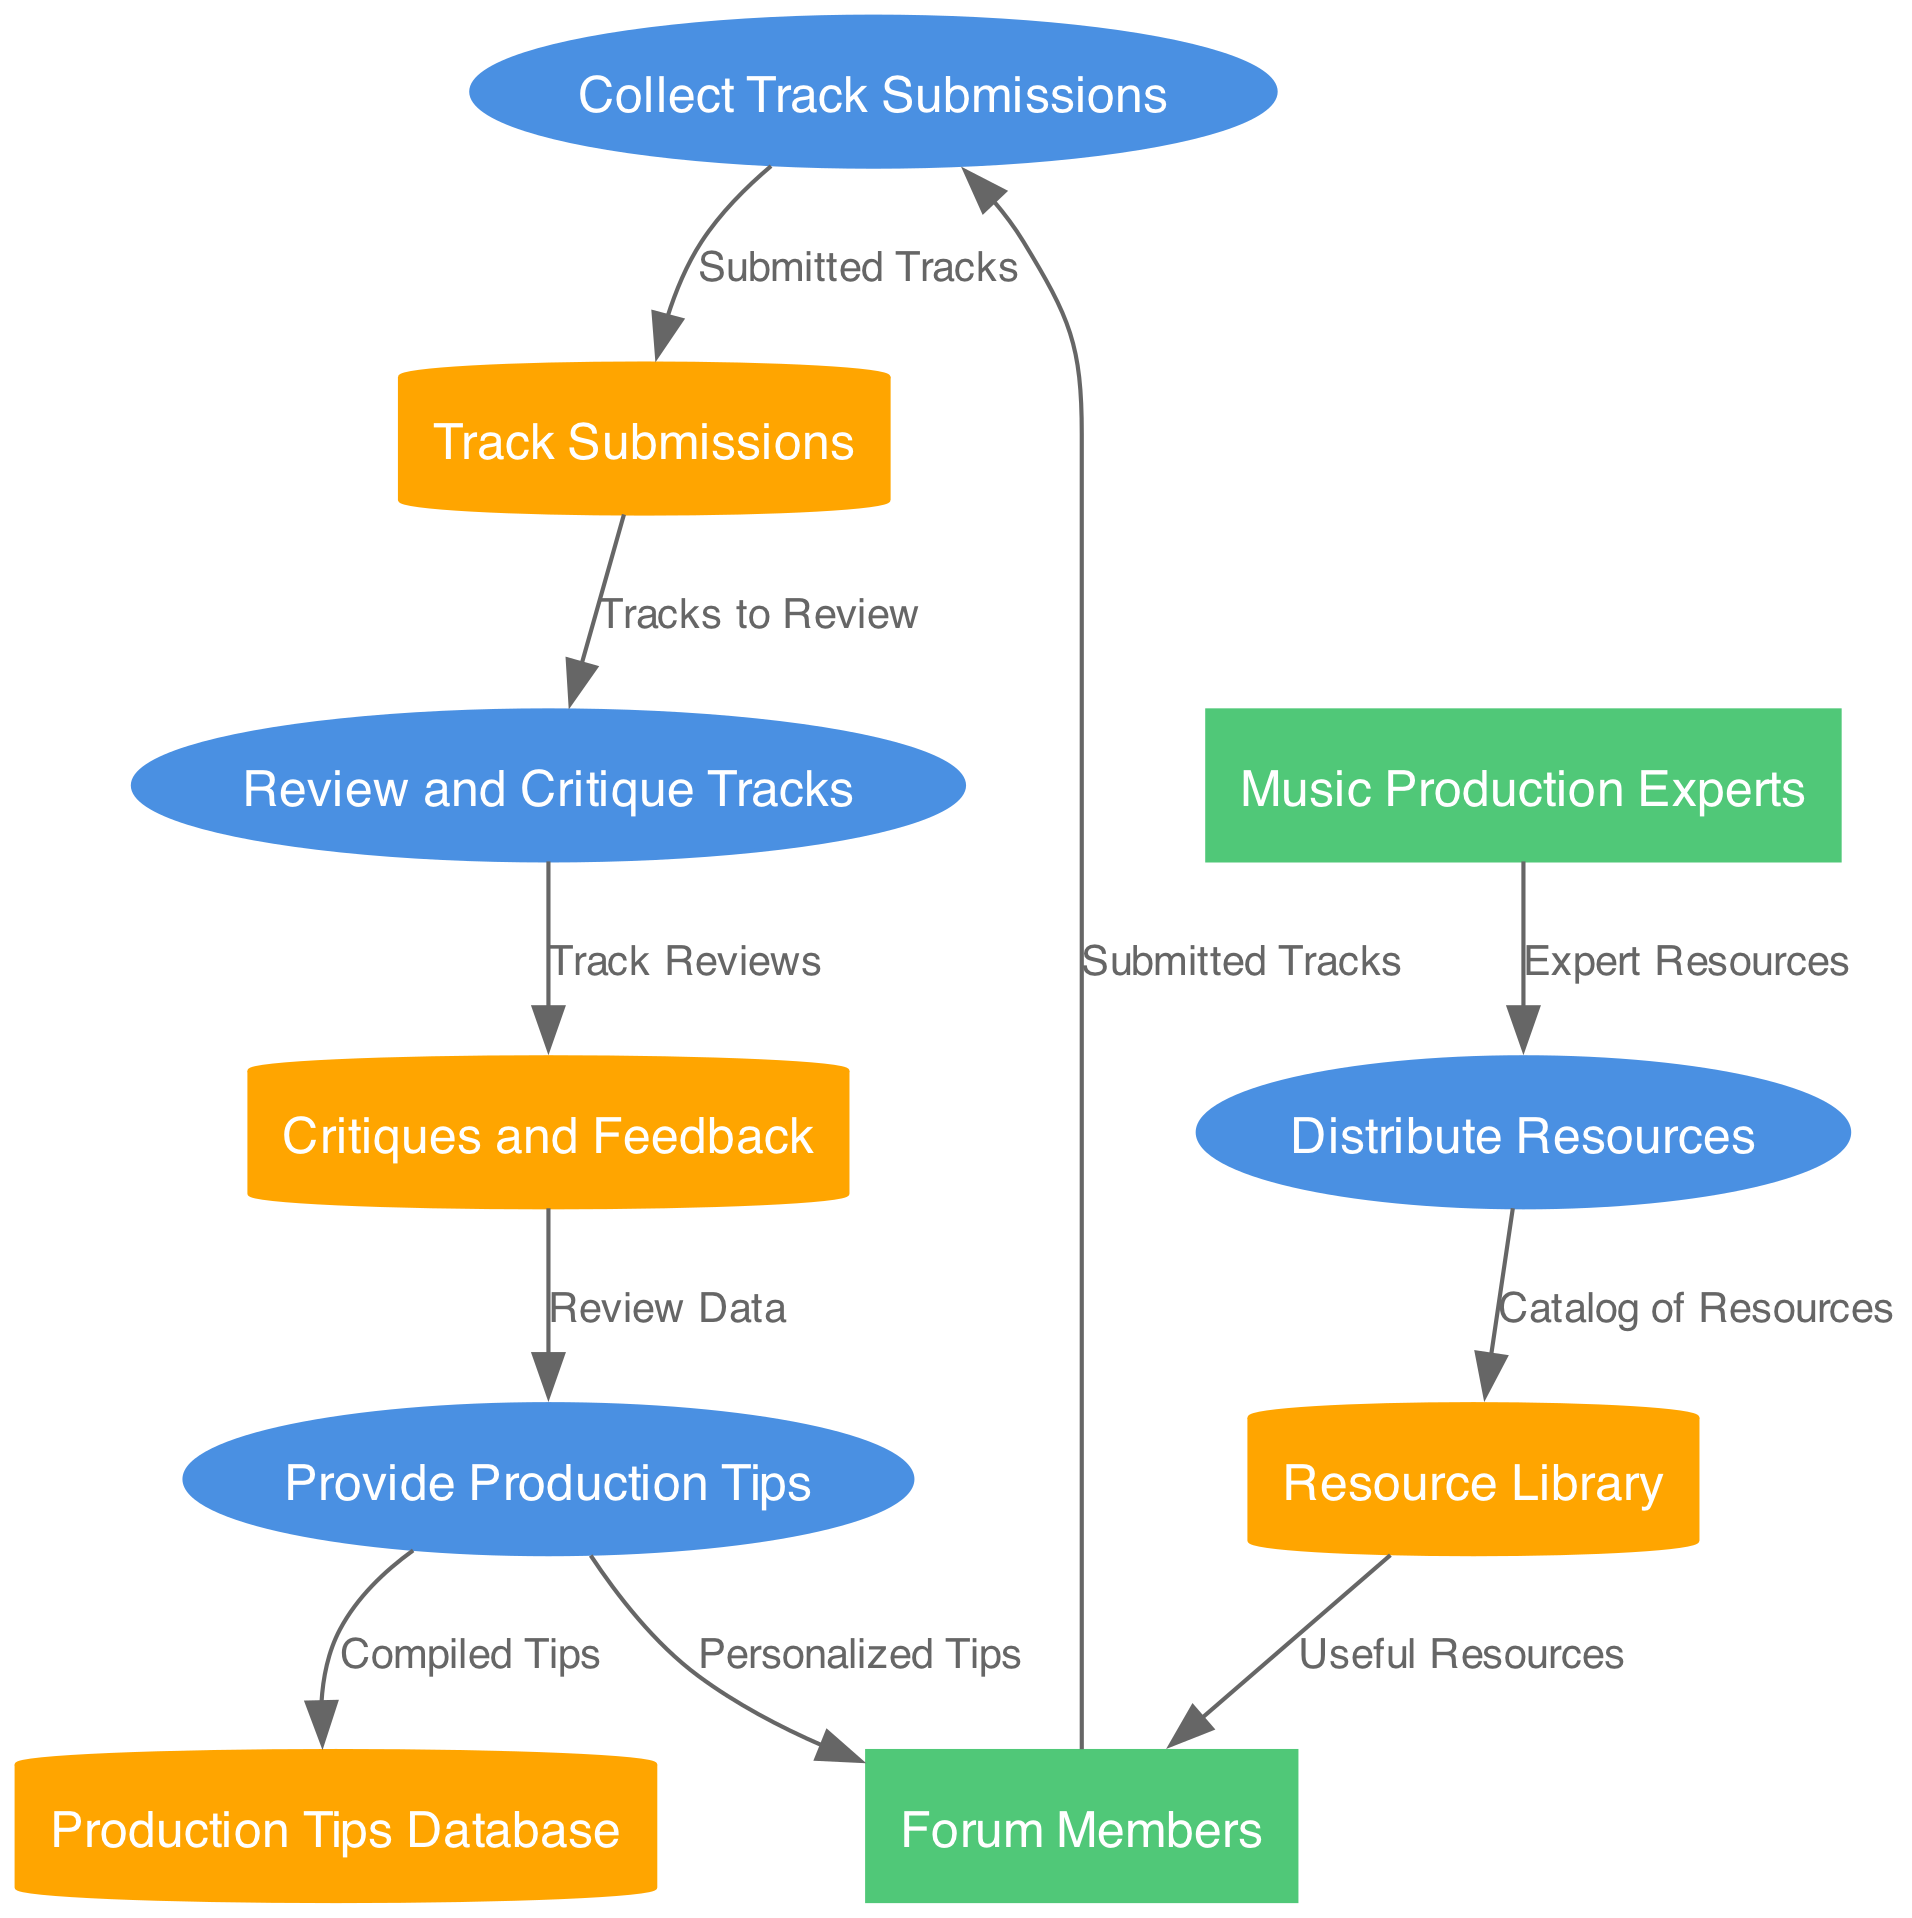What are the external entities in the diagram? The diagram contains two external entities: Forum Members and Music Production Experts. These entities are represented as rectangles in the diagram.
Answer: Forum Members, Music Production Experts How many processes are involved in the music production tips and resources distribution? The diagram displays a total of four processes, which are Collect Track Submissions, Review and Critique Tracks, Provide Production Tips, and Distribute Resources.
Answer: Four What type of data is sent from Forum Members to Collect Track Submissions? The data flow from Forum Members to Collect Track Submissions indicates that it consists of Submitted Tracks. This is shown as a directed edge labeled with this data type.
Answer: Submitted Tracks Which process uses Review Data as input? The Review Data is used as input by the Provide Production Tips process, as indicated by the directed edge labeled with this data that flows from Critiques and Feedback to Provide Production Tips.
Answer: Provide Production Tips How many data stores are present in the diagram? The diagram contains four data stores, including Track Submissions, Critiques and Feedback, Production Tips Database, and Resource Library. Each store is represented as a cylinder in the diagram.
Answer: Four What is the relationship between Review and Critique Tracks and Critiques and Feedback? The Review and Critique Tracks process sends output data, specifically Track Reviews, to the Critiques and Feedback data store. This is depicted by a directed edge between these two entities.
Answer: Track Reviews Which external entity provides resources to the Distribute Resources process? The external entity that provides resources to the Distribute Resources process is Music Production Experts, as shown by the flow of Expert Resources from this entity to the process.
Answer: Music Production Experts What data is provided to Forum Members from Provide Production Tips? Forum Members receive Personalized Tips from the Provide Production Tips process, as indicated by the directed edge labeled with this data.
Answer: Personalized Tips What data flows from Resource Library to Forum Members? The data that flows from Resource Library to Forum Members consists of Useful Resources, as represented by the directed edge labeled with this data in the diagram.
Answer: Useful Resources 